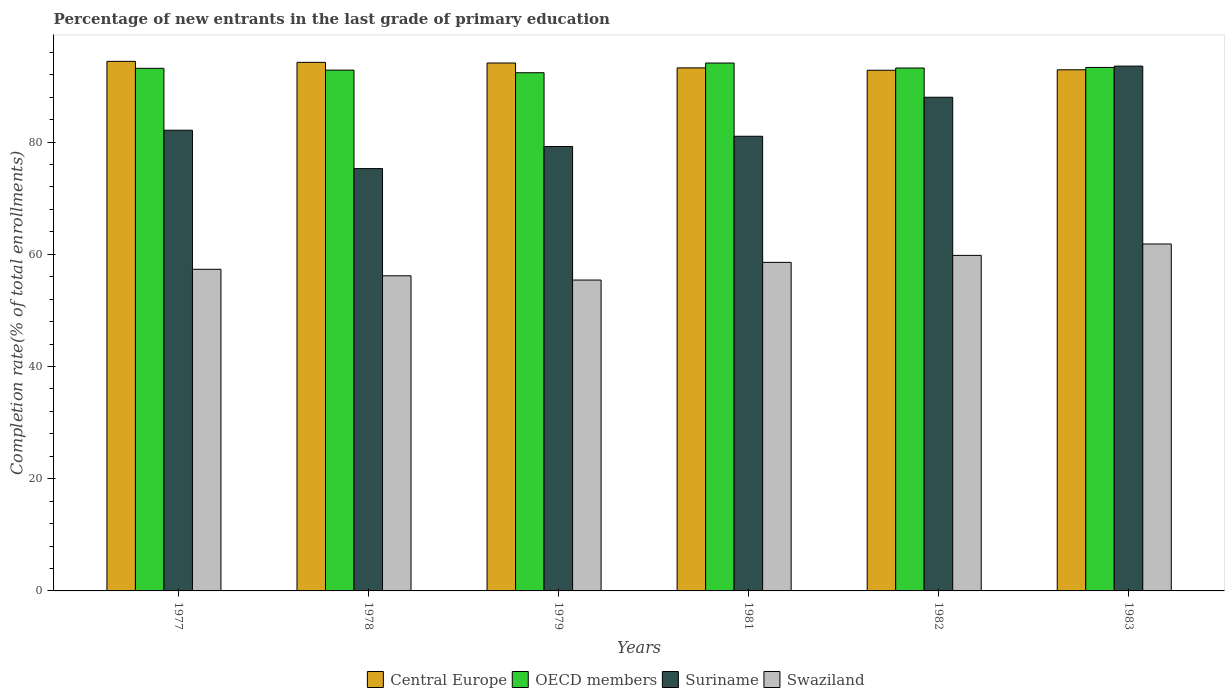Are the number of bars on each tick of the X-axis equal?
Provide a succinct answer. Yes. What is the label of the 1st group of bars from the left?
Your response must be concise. 1977. In how many cases, is the number of bars for a given year not equal to the number of legend labels?
Keep it short and to the point. 0. What is the percentage of new entrants in Swaziland in 1979?
Make the answer very short. 55.4. Across all years, what is the maximum percentage of new entrants in Central Europe?
Your answer should be very brief. 94.38. Across all years, what is the minimum percentage of new entrants in Swaziland?
Provide a succinct answer. 55.4. In which year was the percentage of new entrants in Swaziland minimum?
Offer a very short reply. 1979. What is the total percentage of new entrants in OECD members in the graph?
Ensure brevity in your answer.  558.88. What is the difference between the percentage of new entrants in Swaziland in 1977 and that in 1983?
Your answer should be very brief. -4.51. What is the difference between the percentage of new entrants in OECD members in 1983 and the percentage of new entrants in Suriname in 1979?
Ensure brevity in your answer.  14.09. What is the average percentage of new entrants in OECD members per year?
Provide a succinct answer. 93.15. In the year 1977, what is the difference between the percentage of new entrants in OECD members and percentage of new entrants in Suriname?
Provide a short and direct response. 11.04. What is the ratio of the percentage of new entrants in Swaziland in 1978 to that in 1979?
Keep it short and to the point. 1.01. Is the percentage of new entrants in Suriname in 1979 less than that in 1981?
Your answer should be compact. Yes. What is the difference between the highest and the second highest percentage of new entrants in Suriname?
Offer a very short reply. 5.55. What is the difference between the highest and the lowest percentage of new entrants in Swaziland?
Your answer should be very brief. 6.43. What does the 1st bar from the left in 1979 represents?
Offer a terse response. Central Europe. What does the 4th bar from the right in 1982 represents?
Give a very brief answer. Central Europe. How many bars are there?
Provide a short and direct response. 24. Are the values on the major ticks of Y-axis written in scientific E-notation?
Provide a succinct answer. No. Does the graph contain any zero values?
Provide a succinct answer. No. How many legend labels are there?
Make the answer very short. 4. How are the legend labels stacked?
Your answer should be very brief. Horizontal. What is the title of the graph?
Offer a very short reply. Percentage of new entrants in the last grade of primary education. Does "Luxembourg" appear as one of the legend labels in the graph?
Make the answer very short. No. What is the label or title of the Y-axis?
Your response must be concise. Completion rate(% of total enrollments). What is the Completion rate(% of total enrollments) of Central Europe in 1977?
Your response must be concise. 94.38. What is the Completion rate(% of total enrollments) in OECD members in 1977?
Offer a terse response. 93.14. What is the Completion rate(% of total enrollments) of Suriname in 1977?
Ensure brevity in your answer.  82.11. What is the Completion rate(% of total enrollments) in Swaziland in 1977?
Provide a succinct answer. 57.32. What is the Completion rate(% of total enrollments) in Central Europe in 1978?
Offer a very short reply. 94.2. What is the Completion rate(% of total enrollments) of OECD members in 1978?
Offer a terse response. 92.82. What is the Completion rate(% of total enrollments) of Suriname in 1978?
Your answer should be very brief. 75.27. What is the Completion rate(% of total enrollments) in Swaziland in 1978?
Your answer should be compact. 56.16. What is the Completion rate(% of total enrollments) in Central Europe in 1979?
Give a very brief answer. 94.08. What is the Completion rate(% of total enrollments) of OECD members in 1979?
Offer a terse response. 92.35. What is the Completion rate(% of total enrollments) in Suriname in 1979?
Offer a terse response. 79.21. What is the Completion rate(% of total enrollments) in Swaziland in 1979?
Provide a short and direct response. 55.4. What is the Completion rate(% of total enrollments) in Central Europe in 1981?
Give a very brief answer. 93.22. What is the Completion rate(% of total enrollments) in OECD members in 1981?
Offer a very short reply. 94.08. What is the Completion rate(% of total enrollments) of Suriname in 1981?
Give a very brief answer. 81.03. What is the Completion rate(% of total enrollments) in Swaziland in 1981?
Your answer should be compact. 58.56. What is the Completion rate(% of total enrollments) in Central Europe in 1982?
Your response must be concise. 92.79. What is the Completion rate(% of total enrollments) of OECD members in 1982?
Your answer should be very brief. 93.19. What is the Completion rate(% of total enrollments) of Suriname in 1982?
Your response must be concise. 87.99. What is the Completion rate(% of total enrollments) in Swaziland in 1982?
Offer a very short reply. 59.8. What is the Completion rate(% of total enrollments) in Central Europe in 1983?
Your response must be concise. 92.88. What is the Completion rate(% of total enrollments) of OECD members in 1983?
Your answer should be very brief. 93.3. What is the Completion rate(% of total enrollments) in Suriname in 1983?
Provide a short and direct response. 93.53. What is the Completion rate(% of total enrollments) of Swaziland in 1983?
Provide a succinct answer. 61.83. Across all years, what is the maximum Completion rate(% of total enrollments) in Central Europe?
Provide a succinct answer. 94.38. Across all years, what is the maximum Completion rate(% of total enrollments) in OECD members?
Offer a terse response. 94.08. Across all years, what is the maximum Completion rate(% of total enrollments) in Suriname?
Your response must be concise. 93.53. Across all years, what is the maximum Completion rate(% of total enrollments) of Swaziland?
Offer a terse response. 61.83. Across all years, what is the minimum Completion rate(% of total enrollments) of Central Europe?
Provide a succinct answer. 92.79. Across all years, what is the minimum Completion rate(% of total enrollments) of OECD members?
Your response must be concise. 92.35. Across all years, what is the minimum Completion rate(% of total enrollments) of Suriname?
Offer a terse response. 75.27. Across all years, what is the minimum Completion rate(% of total enrollments) in Swaziland?
Make the answer very short. 55.4. What is the total Completion rate(% of total enrollments) in Central Europe in the graph?
Make the answer very short. 561.55. What is the total Completion rate(% of total enrollments) in OECD members in the graph?
Your response must be concise. 558.88. What is the total Completion rate(% of total enrollments) in Suriname in the graph?
Keep it short and to the point. 499.13. What is the total Completion rate(% of total enrollments) of Swaziland in the graph?
Give a very brief answer. 349.08. What is the difference between the Completion rate(% of total enrollments) of Central Europe in 1977 and that in 1978?
Ensure brevity in your answer.  0.18. What is the difference between the Completion rate(% of total enrollments) in OECD members in 1977 and that in 1978?
Your response must be concise. 0.32. What is the difference between the Completion rate(% of total enrollments) of Suriname in 1977 and that in 1978?
Offer a terse response. 6.84. What is the difference between the Completion rate(% of total enrollments) in Swaziland in 1977 and that in 1978?
Offer a terse response. 1.16. What is the difference between the Completion rate(% of total enrollments) in Central Europe in 1977 and that in 1979?
Ensure brevity in your answer.  0.3. What is the difference between the Completion rate(% of total enrollments) of OECD members in 1977 and that in 1979?
Ensure brevity in your answer.  0.79. What is the difference between the Completion rate(% of total enrollments) of Suriname in 1977 and that in 1979?
Provide a short and direct response. 2.9. What is the difference between the Completion rate(% of total enrollments) of Swaziland in 1977 and that in 1979?
Your answer should be compact. 1.92. What is the difference between the Completion rate(% of total enrollments) in Central Europe in 1977 and that in 1981?
Offer a very short reply. 1.16. What is the difference between the Completion rate(% of total enrollments) in OECD members in 1977 and that in 1981?
Make the answer very short. -0.94. What is the difference between the Completion rate(% of total enrollments) in Suriname in 1977 and that in 1981?
Offer a terse response. 1.08. What is the difference between the Completion rate(% of total enrollments) in Swaziland in 1977 and that in 1981?
Your response must be concise. -1.23. What is the difference between the Completion rate(% of total enrollments) of Central Europe in 1977 and that in 1982?
Your response must be concise. 1.59. What is the difference between the Completion rate(% of total enrollments) in OECD members in 1977 and that in 1982?
Ensure brevity in your answer.  -0.05. What is the difference between the Completion rate(% of total enrollments) of Suriname in 1977 and that in 1982?
Your answer should be compact. -5.88. What is the difference between the Completion rate(% of total enrollments) of Swaziland in 1977 and that in 1982?
Your response must be concise. -2.48. What is the difference between the Completion rate(% of total enrollments) in Central Europe in 1977 and that in 1983?
Make the answer very short. 1.5. What is the difference between the Completion rate(% of total enrollments) in OECD members in 1977 and that in 1983?
Give a very brief answer. -0.15. What is the difference between the Completion rate(% of total enrollments) of Suriname in 1977 and that in 1983?
Provide a short and direct response. -11.43. What is the difference between the Completion rate(% of total enrollments) in Swaziland in 1977 and that in 1983?
Make the answer very short. -4.51. What is the difference between the Completion rate(% of total enrollments) in Central Europe in 1978 and that in 1979?
Provide a succinct answer. 0.12. What is the difference between the Completion rate(% of total enrollments) in OECD members in 1978 and that in 1979?
Give a very brief answer. 0.47. What is the difference between the Completion rate(% of total enrollments) of Suriname in 1978 and that in 1979?
Offer a very short reply. -3.94. What is the difference between the Completion rate(% of total enrollments) of Swaziland in 1978 and that in 1979?
Provide a short and direct response. 0.76. What is the difference between the Completion rate(% of total enrollments) of Central Europe in 1978 and that in 1981?
Give a very brief answer. 0.98. What is the difference between the Completion rate(% of total enrollments) in OECD members in 1978 and that in 1981?
Your answer should be very brief. -1.26. What is the difference between the Completion rate(% of total enrollments) in Suriname in 1978 and that in 1981?
Keep it short and to the point. -5.76. What is the difference between the Completion rate(% of total enrollments) in Swaziland in 1978 and that in 1981?
Give a very brief answer. -2.39. What is the difference between the Completion rate(% of total enrollments) in Central Europe in 1978 and that in 1982?
Make the answer very short. 1.41. What is the difference between the Completion rate(% of total enrollments) in OECD members in 1978 and that in 1982?
Ensure brevity in your answer.  -0.37. What is the difference between the Completion rate(% of total enrollments) of Suriname in 1978 and that in 1982?
Your answer should be compact. -12.72. What is the difference between the Completion rate(% of total enrollments) in Swaziland in 1978 and that in 1982?
Your answer should be very brief. -3.64. What is the difference between the Completion rate(% of total enrollments) of Central Europe in 1978 and that in 1983?
Keep it short and to the point. 1.32. What is the difference between the Completion rate(% of total enrollments) in OECD members in 1978 and that in 1983?
Make the answer very short. -0.48. What is the difference between the Completion rate(% of total enrollments) in Suriname in 1978 and that in 1983?
Your answer should be very brief. -18.26. What is the difference between the Completion rate(% of total enrollments) of Swaziland in 1978 and that in 1983?
Your response must be concise. -5.67. What is the difference between the Completion rate(% of total enrollments) in Central Europe in 1979 and that in 1981?
Make the answer very short. 0.86. What is the difference between the Completion rate(% of total enrollments) in OECD members in 1979 and that in 1981?
Your response must be concise. -1.73. What is the difference between the Completion rate(% of total enrollments) in Suriname in 1979 and that in 1981?
Give a very brief answer. -1.82. What is the difference between the Completion rate(% of total enrollments) of Swaziland in 1979 and that in 1981?
Offer a terse response. -3.15. What is the difference between the Completion rate(% of total enrollments) in Central Europe in 1979 and that in 1982?
Offer a terse response. 1.29. What is the difference between the Completion rate(% of total enrollments) in OECD members in 1979 and that in 1982?
Make the answer very short. -0.84. What is the difference between the Completion rate(% of total enrollments) in Suriname in 1979 and that in 1982?
Offer a very short reply. -8.78. What is the difference between the Completion rate(% of total enrollments) in Swaziland in 1979 and that in 1982?
Give a very brief answer. -4.4. What is the difference between the Completion rate(% of total enrollments) in Central Europe in 1979 and that in 1983?
Ensure brevity in your answer.  1.21. What is the difference between the Completion rate(% of total enrollments) in OECD members in 1979 and that in 1983?
Ensure brevity in your answer.  -0.94. What is the difference between the Completion rate(% of total enrollments) in Suriname in 1979 and that in 1983?
Give a very brief answer. -14.33. What is the difference between the Completion rate(% of total enrollments) of Swaziland in 1979 and that in 1983?
Provide a short and direct response. -6.43. What is the difference between the Completion rate(% of total enrollments) in Central Europe in 1981 and that in 1982?
Your answer should be very brief. 0.43. What is the difference between the Completion rate(% of total enrollments) of OECD members in 1981 and that in 1982?
Ensure brevity in your answer.  0.89. What is the difference between the Completion rate(% of total enrollments) of Suriname in 1981 and that in 1982?
Your response must be concise. -6.96. What is the difference between the Completion rate(% of total enrollments) in Swaziland in 1981 and that in 1982?
Ensure brevity in your answer.  -1.24. What is the difference between the Completion rate(% of total enrollments) of Central Europe in 1981 and that in 1983?
Offer a terse response. 0.34. What is the difference between the Completion rate(% of total enrollments) in OECD members in 1981 and that in 1983?
Provide a short and direct response. 0.79. What is the difference between the Completion rate(% of total enrollments) in Suriname in 1981 and that in 1983?
Offer a very short reply. -12.5. What is the difference between the Completion rate(% of total enrollments) in Swaziland in 1981 and that in 1983?
Provide a succinct answer. -3.27. What is the difference between the Completion rate(% of total enrollments) of Central Europe in 1982 and that in 1983?
Provide a succinct answer. -0.08. What is the difference between the Completion rate(% of total enrollments) in OECD members in 1982 and that in 1983?
Your answer should be very brief. -0.1. What is the difference between the Completion rate(% of total enrollments) in Suriname in 1982 and that in 1983?
Offer a very short reply. -5.55. What is the difference between the Completion rate(% of total enrollments) in Swaziland in 1982 and that in 1983?
Give a very brief answer. -2.03. What is the difference between the Completion rate(% of total enrollments) in Central Europe in 1977 and the Completion rate(% of total enrollments) in OECD members in 1978?
Make the answer very short. 1.56. What is the difference between the Completion rate(% of total enrollments) in Central Europe in 1977 and the Completion rate(% of total enrollments) in Suriname in 1978?
Give a very brief answer. 19.11. What is the difference between the Completion rate(% of total enrollments) in Central Europe in 1977 and the Completion rate(% of total enrollments) in Swaziland in 1978?
Your answer should be very brief. 38.22. What is the difference between the Completion rate(% of total enrollments) in OECD members in 1977 and the Completion rate(% of total enrollments) in Suriname in 1978?
Your answer should be very brief. 17.87. What is the difference between the Completion rate(% of total enrollments) in OECD members in 1977 and the Completion rate(% of total enrollments) in Swaziland in 1978?
Your answer should be compact. 36.98. What is the difference between the Completion rate(% of total enrollments) of Suriname in 1977 and the Completion rate(% of total enrollments) of Swaziland in 1978?
Provide a short and direct response. 25.94. What is the difference between the Completion rate(% of total enrollments) of Central Europe in 1977 and the Completion rate(% of total enrollments) of OECD members in 1979?
Keep it short and to the point. 2.03. What is the difference between the Completion rate(% of total enrollments) in Central Europe in 1977 and the Completion rate(% of total enrollments) in Suriname in 1979?
Ensure brevity in your answer.  15.17. What is the difference between the Completion rate(% of total enrollments) of Central Europe in 1977 and the Completion rate(% of total enrollments) of Swaziland in 1979?
Your answer should be compact. 38.98. What is the difference between the Completion rate(% of total enrollments) in OECD members in 1977 and the Completion rate(% of total enrollments) in Suriname in 1979?
Your answer should be very brief. 13.94. What is the difference between the Completion rate(% of total enrollments) in OECD members in 1977 and the Completion rate(% of total enrollments) in Swaziland in 1979?
Make the answer very short. 37.74. What is the difference between the Completion rate(% of total enrollments) of Suriname in 1977 and the Completion rate(% of total enrollments) of Swaziland in 1979?
Give a very brief answer. 26.7. What is the difference between the Completion rate(% of total enrollments) in Central Europe in 1977 and the Completion rate(% of total enrollments) in OECD members in 1981?
Ensure brevity in your answer.  0.3. What is the difference between the Completion rate(% of total enrollments) of Central Europe in 1977 and the Completion rate(% of total enrollments) of Suriname in 1981?
Provide a succinct answer. 13.35. What is the difference between the Completion rate(% of total enrollments) of Central Europe in 1977 and the Completion rate(% of total enrollments) of Swaziland in 1981?
Your answer should be very brief. 35.82. What is the difference between the Completion rate(% of total enrollments) in OECD members in 1977 and the Completion rate(% of total enrollments) in Suriname in 1981?
Provide a succinct answer. 12.11. What is the difference between the Completion rate(% of total enrollments) of OECD members in 1977 and the Completion rate(% of total enrollments) of Swaziland in 1981?
Make the answer very short. 34.58. What is the difference between the Completion rate(% of total enrollments) of Suriname in 1977 and the Completion rate(% of total enrollments) of Swaziland in 1981?
Provide a succinct answer. 23.55. What is the difference between the Completion rate(% of total enrollments) in Central Europe in 1977 and the Completion rate(% of total enrollments) in OECD members in 1982?
Your answer should be compact. 1.19. What is the difference between the Completion rate(% of total enrollments) of Central Europe in 1977 and the Completion rate(% of total enrollments) of Suriname in 1982?
Offer a terse response. 6.39. What is the difference between the Completion rate(% of total enrollments) of Central Europe in 1977 and the Completion rate(% of total enrollments) of Swaziland in 1982?
Ensure brevity in your answer.  34.58. What is the difference between the Completion rate(% of total enrollments) of OECD members in 1977 and the Completion rate(% of total enrollments) of Suriname in 1982?
Ensure brevity in your answer.  5.16. What is the difference between the Completion rate(% of total enrollments) of OECD members in 1977 and the Completion rate(% of total enrollments) of Swaziland in 1982?
Your answer should be compact. 33.34. What is the difference between the Completion rate(% of total enrollments) of Suriname in 1977 and the Completion rate(% of total enrollments) of Swaziland in 1982?
Provide a short and direct response. 22.31. What is the difference between the Completion rate(% of total enrollments) of Central Europe in 1977 and the Completion rate(% of total enrollments) of OECD members in 1983?
Make the answer very short. 1.09. What is the difference between the Completion rate(% of total enrollments) in Central Europe in 1977 and the Completion rate(% of total enrollments) in Suriname in 1983?
Your response must be concise. 0.85. What is the difference between the Completion rate(% of total enrollments) in Central Europe in 1977 and the Completion rate(% of total enrollments) in Swaziland in 1983?
Offer a very short reply. 32.55. What is the difference between the Completion rate(% of total enrollments) in OECD members in 1977 and the Completion rate(% of total enrollments) in Suriname in 1983?
Your response must be concise. -0.39. What is the difference between the Completion rate(% of total enrollments) of OECD members in 1977 and the Completion rate(% of total enrollments) of Swaziland in 1983?
Provide a short and direct response. 31.31. What is the difference between the Completion rate(% of total enrollments) of Suriname in 1977 and the Completion rate(% of total enrollments) of Swaziland in 1983?
Keep it short and to the point. 20.28. What is the difference between the Completion rate(% of total enrollments) of Central Europe in 1978 and the Completion rate(% of total enrollments) of OECD members in 1979?
Your answer should be very brief. 1.85. What is the difference between the Completion rate(% of total enrollments) in Central Europe in 1978 and the Completion rate(% of total enrollments) in Suriname in 1979?
Ensure brevity in your answer.  15. What is the difference between the Completion rate(% of total enrollments) in Central Europe in 1978 and the Completion rate(% of total enrollments) in Swaziland in 1979?
Ensure brevity in your answer.  38.8. What is the difference between the Completion rate(% of total enrollments) in OECD members in 1978 and the Completion rate(% of total enrollments) in Suriname in 1979?
Provide a short and direct response. 13.61. What is the difference between the Completion rate(% of total enrollments) of OECD members in 1978 and the Completion rate(% of total enrollments) of Swaziland in 1979?
Your answer should be compact. 37.41. What is the difference between the Completion rate(% of total enrollments) in Suriname in 1978 and the Completion rate(% of total enrollments) in Swaziland in 1979?
Offer a very short reply. 19.87. What is the difference between the Completion rate(% of total enrollments) of Central Europe in 1978 and the Completion rate(% of total enrollments) of OECD members in 1981?
Ensure brevity in your answer.  0.12. What is the difference between the Completion rate(% of total enrollments) in Central Europe in 1978 and the Completion rate(% of total enrollments) in Suriname in 1981?
Make the answer very short. 13.17. What is the difference between the Completion rate(% of total enrollments) in Central Europe in 1978 and the Completion rate(% of total enrollments) in Swaziland in 1981?
Your response must be concise. 35.64. What is the difference between the Completion rate(% of total enrollments) in OECD members in 1978 and the Completion rate(% of total enrollments) in Suriname in 1981?
Make the answer very short. 11.79. What is the difference between the Completion rate(% of total enrollments) in OECD members in 1978 and the Completion rate(% of total enrollments) in Swaziland in 1981?
Your response must be concise. 34.26. What is the difference between the Completion rate(% of total enrollments) in Suriname in 1978 and the Completion rate(% of total enrollments) in Swaziland in 1981?
Your answer should be very brief. 16.71. What is the difference between the Completion rate(% of total enrollments) in Central Europe in 1978 and the Completion rate(% of total enrollments) in OECD members in 1982?
Provide a short and direct response. 1.01. What is the difference between the Completion rate(% of total enrollments) of Central Europe in 1978 and the Completion rate(% of total enrollments) of Suriname in 1982?
Offer a very short reply. 6.22. What is the difference between the Completion rate(% of total enrollments) of Central Europe in 1978 and the Completion rate(% of total enrollments) of Swaziland in 1982?
Your answer should be compact. 34.4. What is the difference between the Completion rate(% of total enrollments) in OECD members in 1978 and the Completion rate(% of total enrollments) in Suriname in 1982?
Provide a succinct answer. 4.83. What is the difference between the Completion rate(% of total enrollments) of OECD members in 1978 and the Completion rate(% of total enrollments) of Swaziland in 1982?
Offer a terse response. 33.02. What is the difference between the Completion rate(% of total enrollments) of Suriname in 1978 and the Completion rate(% of total enrollments) of Swaziland in 1982?
Offer a terse response. 15.47. What is the difference between the Completion rate(% of total enrollments) in Central Europe in 1978 and the Completion rate(% of total enrollments) in OECD members in 1983?
Your answer should be compact. 0.91. What is the difference between the Completion rate(% of total enrollments) of Central Europe in 1978 and the Completion rate(% of total enrollments) of Suriname in 1983?
Provide a succinct answer. 0.67. What is the difference between the Completion rate(% of total enrollments) of Central Europe in 1978 and the Completion rate(% of total enrollments) of Swaziland in 1983?
Ensure brevity in your answer.  32.37. What is the difference between the Completion rate(% of total enrollments) of OECD members in 1978 and the Completion rate(% of total enrollments) of Suriname in 1983?
Ensure brevity in your answer.  -0.72. What is the difference between the Completion rate(% of total enrollments) of OECD members in 1978 and the Completion rate(% of total enrollments) of Swaziland in 1983?
Your answer should be compact. 30.99. What is the difference between the Completion rate(% of total enrollments) of Suriname in 1978 and the Completion rate(% of total enrollments) of Swaziland in 1983?
Provide a short and direct response. 13.44. What is the difference between the Completion rate(% of total enrollments) in Central Europe in 1979 and the Completion rate(% of total enrollments) in OECD members in 1981?
Make the answer very short. 0. What is the difference between the Completion rate(% of total enrollments) of Central Europe in 1979 and the Completion rate(% of total enrollments) of Suriname in 1981?
Provide a succinct answer. 13.05. What is the difference between the Completion rate(% of total enrollments) in Central Europe in 1979 and the Completion rate(% of total enrollments) in Swaziland in 1981?
Keep it short and to the point. 35.53. What is the difference between the Completion rate(% of total enrollments) of OECD members in 1979 and the Completion rate(% of total enrollments) of Suriname in 1981?
Offer a terse response. 11.32. What is the difference between the Completion rate(% of total enrollments) of OECD members in 1979 and the Completion rate(% of total enrollments) of Swaziland in 1981?
Provide a short and direct response. 33.8. What is the difference between the Completion rate(% of total enrollments) of Suriname in 1979 and the Completion rate(% of total enrollments) of Swaziland in 1981?
Give a very brief answer. 20.65. What is the difference between the Completion rate(% of total enrollments) of Central Europe in 1979 and the Completion rate(% of total enrollments) of OECD members in 1982?
Your response must be concise. 0.89. What is the difference between the Completion rate(% of total enrollments) of Central Europe in 1979 and the Completion rate(% of total enrollments) of Suriname in 1982?
Give a very brief answer. 6.1. What is the difference between the Completion rate(% of total enrollments) in Central Europe in 1979 and the Completion rate(% of total enrollments) in Swaziland in 1982?
Keep it short and to the point. 34.28. What is the difference between the Completion rate(% of total enrollments) of OECD members in 1979 and the Completion rate(% of total enrollments) of Suriname in 1982?
Offer a terse response. 4.37. What is the difference between the Completion rate(% of total enrollments) in OECD members in 1979 and the Completion rate(% of total enrollments) in Swaziland in 1982?
Ensure brevity in your answer.  32.55. What is the difference between the Completion rate(% of total enrollments) of Suriname in 1979 and the Completion rate(% of total enrollments) of Swaziland in 1982?
Offer a terse response. 19.41. What is the difference between the Completion rate(% of total enrollments) of Central Europe in 1979 and the Completion rate(% of total enrollments) of OECD members in 1983?
Provide a short and direct response. 0.79. What is the difference between the Completion rate(% of total enrollments) of Central Europe in 1979 and the Completion rate(% of total enrollments) of Suriname in 1983?
Make the answer very short. 0.55. What is the difference between the Completion rate(% of total enrollments) in Central Europe in 1979 and the Completion rate(% of total enrollments) in Swaziland in 1983?
Keep it short and to the point. 32.25. What is the difference between the Completion rate(% of total enrollments) in OECD members in 1979 and the Completion rate(% of total enrollments) in Suriname in 1983?
Offer a very short reply. -1.18. What is the difference between the Completion rate(% of total enrollments) of OECD members in 1979 and the Completion rate(% of total enrollments) of Swaziland in 1983?
Provide a succinct answer. 30.52. What is the difference between the Completion rate(% of total enrollments) in Suriname in 1979 and the Completion rate(% of total enrollments) in Swaziland in 1983?
Keep it short and to the point. 17.38. What is the difference between the Completion rate(% of total enrollments) of Central Europe in 1981 and the Completion rate(% of total enrollments) of OECD members in 1982?
Give a very brief answer. 0.03. What is the difference between the Completion rate(% of total enrollments) in Central Europe in 1981 and the Completion rate(% of total enrollments) in Suriname in 1982?
Your answer should be compact. 5.23. What is the difference between the Completion rate(% of total enrollments) of Central Europe in 1981 and the Completion rate(% of total enrollments) of Swaziland in 1982?
Keep it short and to the point. 33.42. What is the difference between the Completion rate(% of total enrollments) in OECD members in 1981 and the Completion rate(% of total enrollments) in Suriname in 1982?
Provide a short and direct response. 6.1. What is the difference between the Completion rate(% of total enrollments) of OECD members in 1981 and the Completion rate(% of total enrollments) of Swaziland in 1982?
Your answer should be very brief. 34.28. What is the difference between the Completion rate(% of total enrollments) of Suriname in 1981 and the Completion rate(% of total enrollments) of Swaziland in 1982?
Give a very brief answer. 21.23. What is the difference between the Completion rate(% of total enrollments) in Central Europe in 1981 and the Completion rate(% of total enrollments) in OECD members in 1983?
Keep it short and to the point. -0.07. What is the difference between the Completion rate(% of total enrollments) of Central Europe in 1981 and the Completion rate(% of total enrollments) of Suriname in 1983?
Offer a terse response. -0.31. What is the difference between the Completion rate(% of total enrollments) of Central Europe in 1981 and the Completion rate(% of total enrollments) of Swaziland in 1983?
Provide a short and direct response. 31.39. What is the difference between the Completion rate(% of total enrollments) in OECD members in 1981 and the Completion rate(% of total enrollments) in Suriname in 1983?
Provide a short and direct response. 0.55. What is the difference between the Completion rate(% of total enrollments) in OECD members in 1981 and the Completion rate(% of total enrollments) in Swaziland in 1983?
Make the answer very short. 32.25. What is the difference between the Completion rate(% of total enrollments) in Suriname in 1981 and the Completion rate(% of total enrollments) in Swaziland in 1983?
Ensure brevity in your answer.  19.2. What is the difference between the Completion rate(% of total enrollments) in Central Europe in 1982 and the Completion rate(% of total enrollments) in OECD members in 1983?
Your answer should be compact. -0.5. What is the difference between the Completion rate(% of total enrollments) of Central Europe in 1982 and the Completion rate(% of total enrollments) of Suriname in 1983?
Your answer should be compact. -0.74. What is the difference between the Completion rate(% of total enrollments) of Central Europe in 1982 and the Completion rate(% of total enrollments) of Swaziland in 1983?
Keep it short and to the point. 30.96. What is the difference between the Completion rate(% of total enrollments) in OECD members in 1982 and the Completion rate(% of total enrollments) in Suriname in 1983?
Make the answer very short. -0.34. What is the difference between the Completion rate(% of total enrollments) of OECD members in 1982 and the Completion rate(% of total enrollments) of Swaziland in 1983?
Offer a very short reply. 31.36. What is the difference between the Completion rate(% of total enrollments) in Suriname in 1982 and the Completion rate(% of total enrollments) in Swaziland in 1983?
Make the answer very short. 26.16. What is the average Completion rate(% of total enrollments) in Central Europe per year?
Your answer should be very brief. 93.59. What is the average Completion rate(% of total enrollments) in OECD members per year?
Your answer should be compact. 93.15. What is the average Completion rate(% of total enrollments) in Suriname per year?
Provide a succinct answer. 83.19. What is the average Completion rate(% of total enrollments) in Swaziland per year?
Ensure brevity in your answer.  58.18. In the year 1977, what is the difference between the Completion rate(% of total enrollments) in Central Europe and Completion rate(% of total enrollments) in OECD members?
Your answer should be compact. 1.24. In the year 1977, what is the difference between the Completion rate(% of total enrollments) in Central Europe and Completion rate(% of total enrollments) in Suriname?
Your response must be concise. 12.27. In the year 1977, what is the difference between the Completion rate(% of total enrollments) of Central Europe and Completion rate(% of total enrollments) of Swaziland?
Provide a succinct answer. 37.06. In the year 1977, what is the difference between the Completion rate(% of total enrollments) in OECD members and Completion rate(% of total enrollments) in Suriname?
Provide a succinct answer. 11.04. In the year 1977, what is the difference between the Completion rate(% of total enrollments) in OECD members and Completion rate(% of total enrollments) in Swaziland?
Your answer should be very brief. 35.82. In the year 1977, what is the difference between the Completion rate(% of total enrollments) of Suriname and Completion rate(% of total enrollments) of Swaziland?
Ensure brevity in your answer.  24.78. In the year 1978, what is the difference between the Completion rate(% of total enrollments) in Central Europe and Completion rate(% of total enrollments) in OECD members?
Your response must be concise. 1.38. In the year 1978, what is the difference between the Completion rate(% of total enrollments) in Central Europe and Completion rate(% of total enrollments) in Suriname?
Make the answer very short. 18.93. In the year 1978, what is the difference between the Completion rate(% of total enrollments) of Central Europe and Completion rate(% of total enrollments) of Swaziland?
Provide a short and direct response. 38.04. In the year 1978, what is the difference between the Completion rate(% of total enrollments) in OECD members and Completion rate(% of total enrollments) in Suriname?
Ensure brevity in your answer.  17.55. In the year 1978, what is the difference between the Completion rate(% of total enrollments) of OECD members and Completion rate(% of total enrollments) of Swaziland?
Make the answer very short. 36.66. In the year 1978, what is the difference between the Completion rate(% of total enrollments) in Suriname and Completion rate(% of total enrollments) in Swaziland?
Provide a short and direct response. 19.11. In the year 1979, what is the difference between the Completion rate(% of total enrollments) in Central Europe and Completion rate(% of total enrollments) in OECD members?
Give a very brief answer. 1.73. In the year 1979, what is the difference between the Completion rate(% of total enrollments) of Central Europe and Completion rate(% of total enrollments) of Suriname?
Offer a very short reply. 14.88. In the year 1979, what is the difference between the Completion rate(% of total enrollments) in Central Europe and Completion rate(% of total enrollments) in Swaziland?
Provide a short and direct response. 38.68. In the year 1979, what is the difference between the Completion rate(% of total enrollments) of OECD members and Completion rate(% of total enrollments) of Suriname?
Keep it short and to the point. 13.15. In the year 1979, what is the difference between the Completion rate(% of total enrollments) in OECD members and Completion rate(% of total enrollments) in Swaziland?
Offer a terse response. 36.95. In the year 1979, what is the difference between the Completion rate(% of total enrollments) of Suriname and Completion rate(% of total enrollments) of Swaziland?
Your response must be concise. 23.8. In the year 1981, what is the difference between the Completion rate(% of total enrollments) in Central Europe and Completion rate(% of total enrollments) in OECD members?
Your answer should be compact. -0.86. In the year 1981, what is the difference between the Completion rate(% of total enrollments) of Central Europe and Completion rate(% of total enrollments) of Suriname?
Give a very brief answer. 12.19. In the year 1981, what is the difference between the Completion rate(% of total enrollments) of Central Europe and Completion rate(% of total enrollments) of Swaziland?
Provide a short and direct response. 34.66. In the year 1981, what is the difference between the Completion rate(% of total enrollments) of OECD members and Completion rate(% of total enrollments) of Suriname?
Keep it short and to the point. 13.05. In the year 1981, what is the difference between the Completion rate(% of total enrollments) in OECD members and Completion rate(% of total enrollments) in Swaziland?
Provide a short and direct response. 35.52. In the year 1981, what is the difference between the Completion rate(% of total enrollments) of Suriname and Completion rate(% of total enrollments) of Swaziland?
Provide a short and direct response. 22.47. In the year 1982, what is the difference between the Completion rate(% of total enrollments) in Central Europe and Completion rate(% of total enrollments) in OECD members?
Provide a succinct answer. -0.4. In the year 1982, what is the difference between the Completion rate(% of total enrollments) of Central Europe and Completion rate(% of total enrollments) of Suriname?
Your answer should be very brief. 4.81. In the year 1982, what is the difference between the Completion rate(% of total enrollments) in Central Europe and Completion rate(% of total enrollments) in Swaziland?
Your response must be concise. 32.99. In the year 1982, what is the difference between the Completion rate(% of total enrollments) of OECD members and Completion rate(% of total enrollments) of Suriname?
Your response must be concise. 5.21. In the year 1982, what is the difference between the Completion rate(% of total enrollments) of OECD members and Completion rate(% of total enrollments) of Swaziland?
Provide a short and direct response. 33.39. In the year 1982, what is the difference between the Completion rate(% of total enrollments) of Suriname and Completion rate(% of total enrollments) of Swaziland?
Your answer should be very brief. 28.19. In the year 1983, what is the difference between the Completion rate(% of total enrollments) in Central Europe and Completion rate(% of total enrollments) in OECD members?
Offer a very short reply. -0.42. In the year 1983, what is the difference between the Completion rate(% of total enrollments) in Central Europe and Completion rate(% of total enrollments) in Suriname?
Your response must be concise. -0.66. In the year 1983, what is the difference between the Completion rate(% of total enrollments) in Central Europe and Completion rate(% of total enrollments) in Swaziland?
Your answer should be compact. 31.05. In the year 1983, what is the difference between the Completion rate(% of total enrollments) in OECD members and Completion rate(% of total enrollments) in Suriname?
Your answer should be very brief. -0.24. In the year 1983, what is the difference between the Completion rate(% of total enrollments) in OECD members and Completion rate(% of total enrollments) in Swaziland?
Your response must be concise. 31.46. In the year 1983, what is the difference between the Completion rate(% of total enrollments) of Suriname and Completion rate(% of total enrollments) of Swaziland?
Keep it short and to the point. 31.7. What is the ratio of the Completion rate(% of total enrollments) of Suriname in 1977 to that in 1978?
Your response must be concise. 1.09. What is the ratio of the Completion rate(% of total enrollments) of Swaziland in 1977 to that in 1978?
Keep it short and to the point. 1.02. What is the ratio of the Completion rate(% of total enrollments) of OECD members in 1977 to that in 1979?
Provide a short and direct response. 1.01. What is the ratio of the Completion rate(% of total enrollments) in Suriname in 1977 to that in 1979?
Ensure brevity in your answer.  1.04. What is the ratio of the Completion rate(% of total enrollments) of Swaziland in 1977 to that in 1979?
Keep it short and to the point. 1.03. What is the ratio of the Completion rate(% of total enrollments) of Central Europe in 1977 to that in 1981?
Provide a short and direct response. 1.01. What is the ratio of the Completion rate(% of total enrollments) of Suriname in 1977 to that in 1981?
Your response must be concise. 1.01. What is the ratio of the Completion rate(% of total enrollments) in Swaziland in 1977 to that in 1981?
Offer a terse response. 0.98. What is the ratio of the Completion rate(% of total enrollments) in Central Europe in 1977 to that in 1982?
Make the answer very short. 1.02. What is the ratio of the Completion rate(% of total enrollments) in OECD members in 1977 to that in 1982?
Give a very brief answer. 1. What is the ratio of the Completion rate(% of total enrollments) in Suriname in 1977 to that in 1982?
Offer a very short reply. 0.93. What is the ratio of the Completion rate(% of total enrollments) of Swaziland in 1977 to that in 1982?
Your response must be concise. 0.96. What is the ratio of the Completion rate(% of total enrollments) in Central Europe in 1977 to that in 1983?
Your answer should be compact. 1.02. What is the ratio of the Completion rate(% of total enrollments) in OECD members in 1977 to that in 1983?
Offer a very short reply. 1. What is the ratio of the Completion rate(% of total enrollments) in Suriname in 1977 to that in 1983?
Give a very brief answer. 0.88. What is the ratio of the Completion rate(% of total enrollments) in Swaziland in 1977 to that in 1983?
Make the answer very short. 0.93. What is the ratio of the Completion rate(% of total enrollments) in Suriname in 1978 to that in 1979?
Provide a succinct answer. 0.95. What is the ratio of the Completion rate(% of total enrollments) of Swaziland in 1978 to that in 1979?
Provide a succinct answer. 1.01. What is the ratio of the Completion rate(% of total enrollments) of Central Europe in 1978 to that in 1981?
Your response must be concise. 1.01. What is the ratio of the Completion rate(% of total enrollments) in OECD members in 1978 to that in 1981?
Make the answer very short. 0.99. What is the ratio of the Completion rate(% of total enrollments) in Suriname in 1978 to that in 1981?
Ensure brevity in your answer.  0.93. What is the ratio of the Completion rate(% of total enrollments) of Swaziland in 1978 to that in 1981?
Offer a terse response. 0.96. What is the ratio of the Completion rate(% of total enrollments) of Central Europe in 1978 to that in 1982?
Your answer should be very brief. 1.02. What is the ratio of the Completion rate(% of total enrollments) of OECD members in 1978 to that in 1982?
Make the answer very short. 1. What is the ratio of the Completion rate(% of total enrollments) in Suriname in 1978 to that in 1982?
Your answer should be compact. 0.86. What is the ratio of the Completion rate(% of total enrollments) in Swaziland in 1978 to that in 1982?
Provide a succinct answer. 0.94. What is the ratio of the Completion rate(% of total enrollments) of Central Europe in 1978 to that in 1983?
Provide a succinct answer. 1.01. What is the ratio of the Completion rate(% of total enrollments) in Suriname in 1978 to that in 1983?
Your answer should be compact. 0.8. What is the ratio of the Completion rate(% of total enrollments) in Swaziland in 1978 to that in 1983?
Your response must be concise. 0.91. What is the ratio of the Completion rate(% of total enrollments) in Central Europe in 1979 to that in 1981?
Offer a very short reply. 1.01. What is the ratio of the Completion rate(% of total enrollments) in OECD members in 1979 to that in 1981?
Offer a very short reply. 0.98. What is the ratio of the Completion rate(% of total enrollments) in Suriname in 1979 to that in 1981?
Ensure brevity in your answer.  0.98. What is the ratio of the Completion rate(% of total enrollments) in Swaziland in 1979 to that in 1981?
Make the answer very short. 0.95. What is the ratio of the Completion rate(% of total enrollments) of Central Europe in 1979 to that in 1982?
Offer a very short reply. 1.01. What is the ratio of the Completion rate(% of total enrollments) in OECD members in 1979 to that in 1982?
Your answer should be compact. 0.99. What is the ratio of the Completion rate(% of total enrollments) in Suriname in 1979 to that in 1982?
Give a very brief answer. 0.9. What is the ratio of the Completion rate(% of total enrollments) of Swaziland in 1979 to that in 1982?
Your response must be concise. 0.93. What is the ratio of the Completion rate(% of total enrollments) of Suriname in 1979 to that in 1983?
Make the answer very short. 0.85. What is the ratio of the Completion rate(% of total enrollments) of Swaziland in 1979 to that in 1983?
Give a very brief answer. 0.9. What is the ratio of the Completion rate(% of total enrollments) of Central Europe in 1981 to that in 1982?
Provide a short and direct response. 1. What is the ratio of the Completion rate(% of total enrollments) of OECD members in 1981 to that in 1982?
Your answer should be very brief. 1.01. What is the ratio of the Completion rate(% of total enrollments) in Suriname in 1981 to that in 1982?
Keep it short and to the point. 0.92. What is the ratio of the Completion rate(% of total enrollments) in Swaziland in 1981 to that in 1982?
Keep it short and to the point. 0.98. What is the ratio of the Completion rate(% of total enrollments) of Central Europe in 1981 to that in 1983?
Offer a very short reply. 1. What is the ratio of the Completion rate(% of total enrollments) of OECD members in 1981 to that in 1983?
Your answer should be very brief. 1.01. What is the ratio of the Completion rate(% of total enrollments) in Suriname in 1981 to that in 1983?
Your answer should be very brief. 0.87. What is the ratio of the Completion rate(% of total enrollments) in Swaziland in 1981 to that in 1983?
Your answer should be very brief. 0.95. What is the ratio of the Completion rate(% of total enrollments) of Suriname in 1982 to that in 1983?
Provide a short and direct response. 0.94. What is the ratio of the Completion rate(% of total enrollments) in Swaziland in 1982 to that in 1983?
Ensure brevity in your answer.  0.97. What is the difference between the highest and the second highest Completion rate(% of total enrollments) of Central Europe?
Your answer should be compact. 0.18. What is the difference between the highest and the second highest Completion rate(% of total enrollments) of OECD members?
Offer a very short reply. 0.79. What is the difference between the highest and the second highest Completion rate(% of total enrollments) in Suriname?
Give a very brief answer. 5.55. What is the difference between the highest and the second highest Completion rate(% of total enrollments) of Swaziland?
Your answer should be compact. 2.03. What is the difference between the highest and the lowest Completion rate(% of total enrollments) in Central Europe?
Offer a terse response. 1.59. What is the difference between the highest and the lowest Completion rate(% of total enrollments) of OECD members?
Your answer should be compact. 1.73. What is the difference between the highest and the lowest Completion rate(% of total enrollments) in Suriname?
Give a very brief answer. 18.26. What is the difference between the highest and the lowest Completion rate(% of total enrollments) of Swaziland?
Your answer should be very brief. 6.43. 